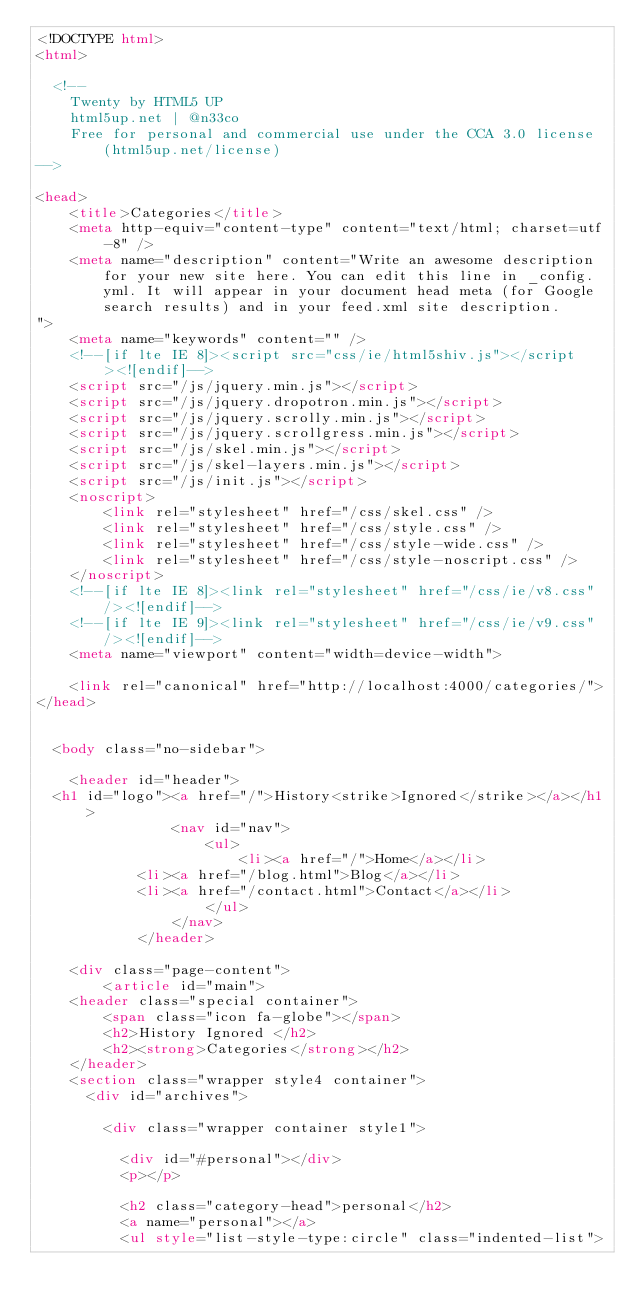<code> <loc_0><loc_0><loc_500><loc_500><_HTML_><!DOCTYPE html>
<html>

  <!--
	Twenty by HTML5 UP
	html5up.net | @n33co
	Free for personal and commercial use under the CCA 3.0 license (html5up.net/license)
-->

<head>
    <title>Categories</title>
    <meta http-equiv="content-type" content="text/html; charset=utf-8" />
    <meta name="description" content="Write an awesome description for your new site here. You can edit this line in _config.yml. It will appear in your document head meta (for Google search results) and in your feed.xml site description.
">
    <meta name="keywords" content="" />
    <!--[if lte IE 8]><script src="css/ie/html5shiv.js"></script><![endif]-->
    <script src="/js/jquery.min.js"></script>
    <script src="/js/jquery.dropotron.min.js"></script>
    <script src="/js/jquery.scrolly.min.js"></script>
    <script src="/js/jquery.scrollgress.min.js"></script>
    <script src="/js/skel.min.js"></script>
    <script src="/js/skel-layers.min.js"></script>
    <script src="/js/init.js"></script>
    <noscript>
        <link rel="stylesheet" href="/css/skel.css" />
        <link rel="stylesheet" href="/css/style.css" />
        <link rel="stylesheet" href="/css/style-wide.css" />
        <link rel="stylesheet" href="/css/style-noscript.css" />
    </noscript>
    <!--[if lte IE 8]><link rel="stylesheet" href="/css/ie/v8.css" /><![endif]-->
    <!--[if lte IE 9]><link rel="stylesheet" href="/css/ie/v9.css" /><![endif]-->
    <meta name="viewport" content="width=device-width">

    <link rel="canonical" href="http://localhost:4000/categories/">
</head>


  <body class="no-sidebar">

    <header id="header">
  <h1 id="logo"><a href="/">History<strike>Ignored</strike></a></h1>
				<nav id="nav">
					<ul>
						<li><a href="/">Home</a></li>
            <li><a href="/blog.html">Blog</a></li>
            <li><a href="/contact.html">Contact</a></li>
					</ul>
				</nav>
			</header>

    <div class="page-content">
        <article id="main">
    <header class="special container">
        <span class="icon fa-globe"></span>
        <h2>History Ignored </h2>
        <h2><strong>Categories</strong></h2>
    </header>
    <section class="wrapper style4 container">
      <div id="archives">
      
        <div class="wrapper container style1">
          
          <div id="#personal"></div>
          <p></p>

          <h2 class="category-head">personal</h2>
          <a name="personal"></a>
          <ul style="list-style-type:circle" class="indented-list">
            </code> 